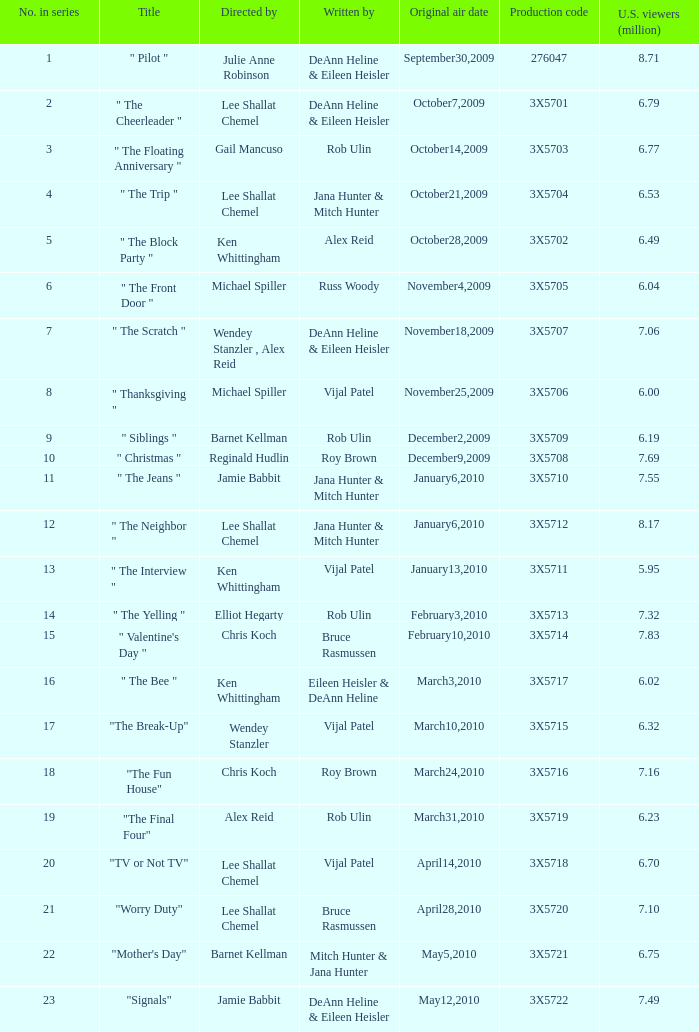79 million u.s. viewers with their episodes? 1.0. 